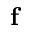<formula> <loc_0><loc_0><loc_500><loc_500>f</formula> 